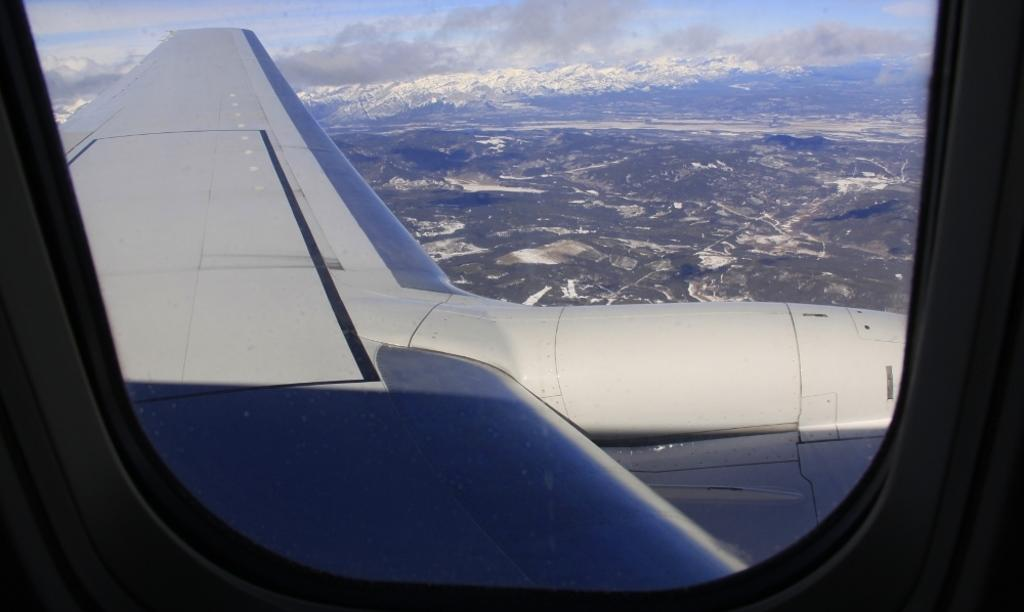What is the main subject of the image? The main subject of the image is a wing of an airplane. What type of landscape can be seen in the background of the image? Mountains are visible in the background of the image. How would you describe the weather in the image? The sky is cloudy in the image. What is present in the foreground of the image? There is a window in the foreground of the image. Can you tell me the value of the cemetery located in the middle of the image? There is no cemetery present in the image, and therefore no value can be assigned to it. 